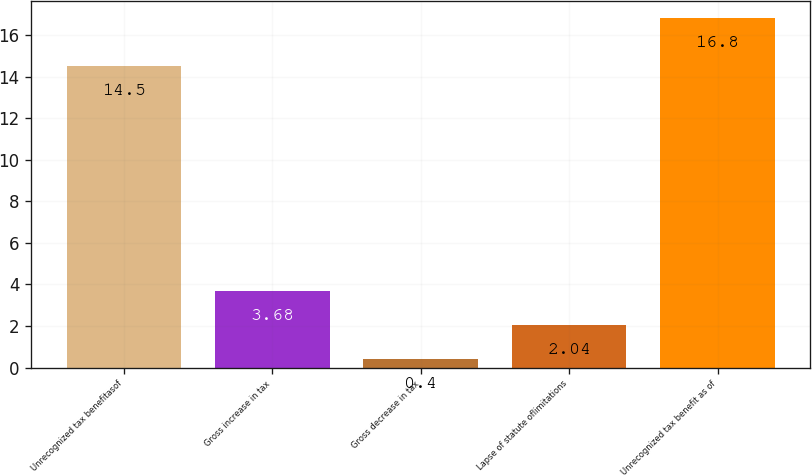<chart> <loc_0><loc_0><loc_500><loc_500><bar_chart><fcel>Unrecognized tax benefitasof<fcel>Gross increase in tax<fcel>Gross decrease in tax<fcel>Lapse of statute oflimitations<fcel>Unrecognized tax benefit as of<nl><fcel>14.5<fcel>3.68<fcel>0.4<fcel>2.04<fcel>16.8<nl></chart> 